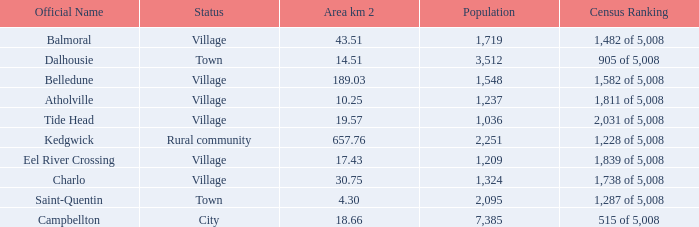When the communities name is Balmoral and the area is over 43.51 kilometers squared, what's the total population amount? 0.0. 